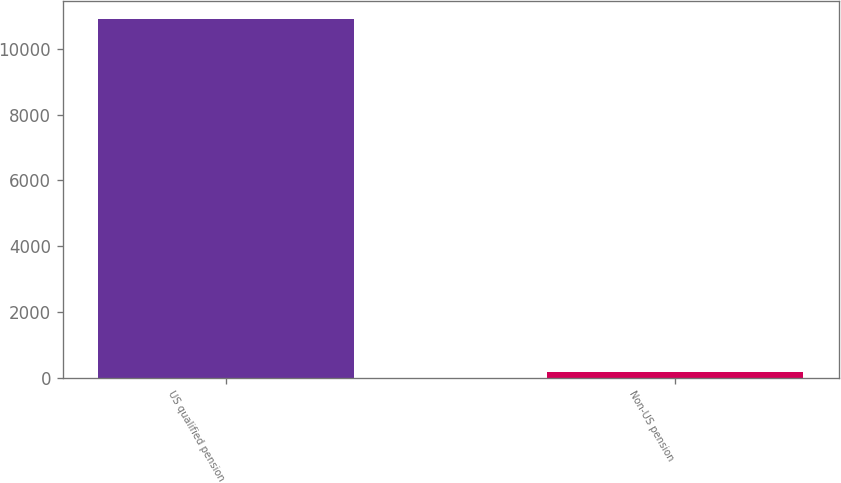Convert chart. <chart><loc_0><loc_0><loc_500><loc_500><bar_chart><fcel>US qualified pension<fcel>Non-US pension<nl><fcel>10918<fcel>180<nl></chart> 